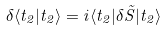<formula> <loc_0><loc_0><loc_500><loc_500>\delta \langle t _ { 2 } | t _ { 2 } \rangle = i \langle t _ { 2 } | \delta \tilde { S } | t _ { 2 } \rangle</formula> 